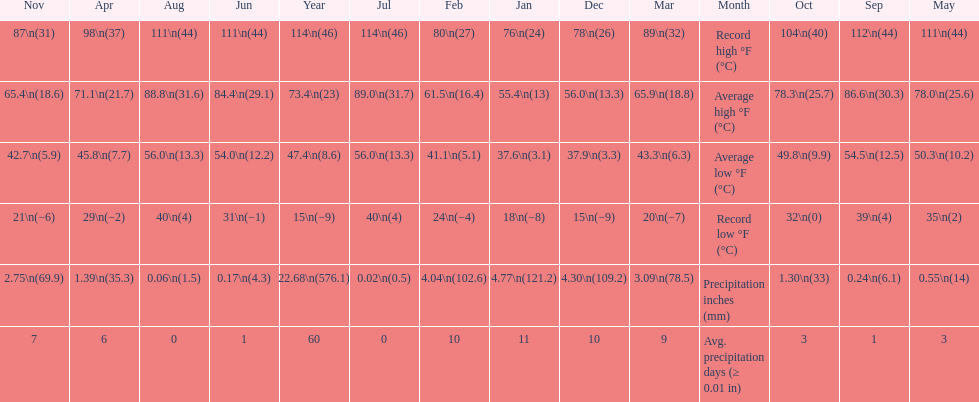How many months how a record low below 25 degrees? 6. 